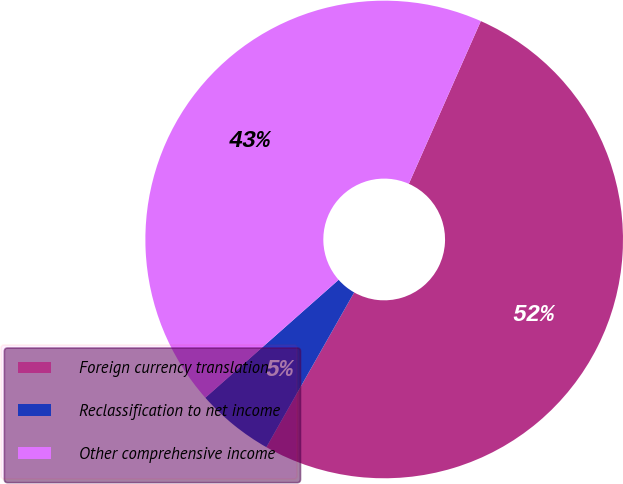Convert chart. <chart><loc_0><loc_0><loc_500><loc_500><pie_chart><fcel>Foreign currency translation<fcel>Reclassification to net income<fcel>Other comprehensive income<nl><fcel>51.58%<fcel>5.26%<fcel>43.16%<nl></chart> 